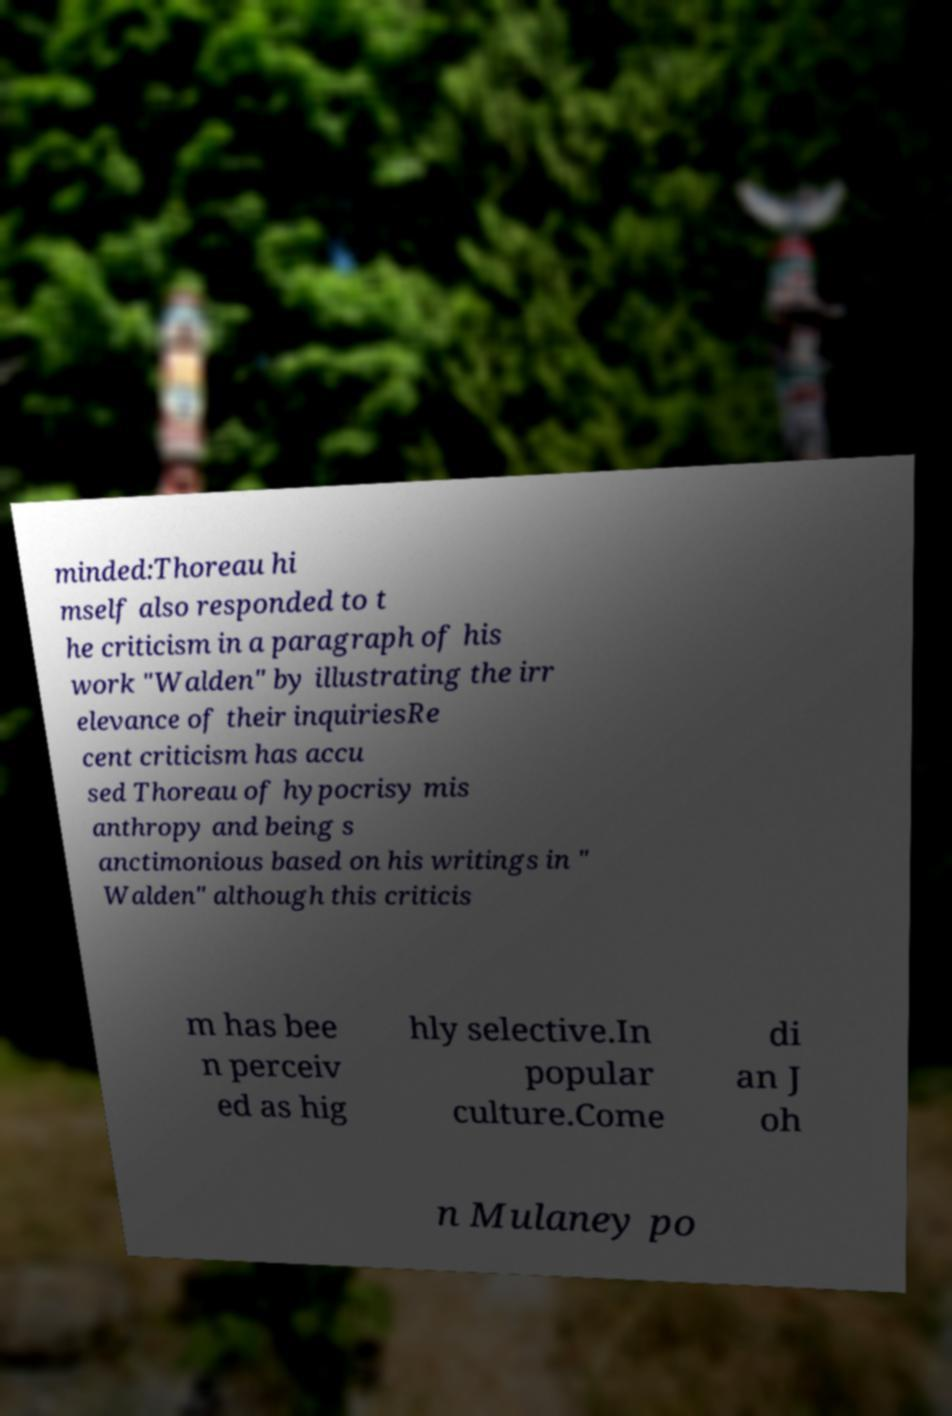There's text embedded in this image that I need extracted. Can you transcribe it verbatim? minded:Thoreau hi mself also responded to t he criticism in a paragraph of his work "Walden" by illustrating the irr elevance of their inquiriesRe cent criticism has accu sed Thoreau of hypocrisy mis anthropy and being s anctimonious based on his writings in " Walden" although this criticis m has bee n perceiv ed as hig hly selective.In popular culture.Come di an J oh n Mulaney po 